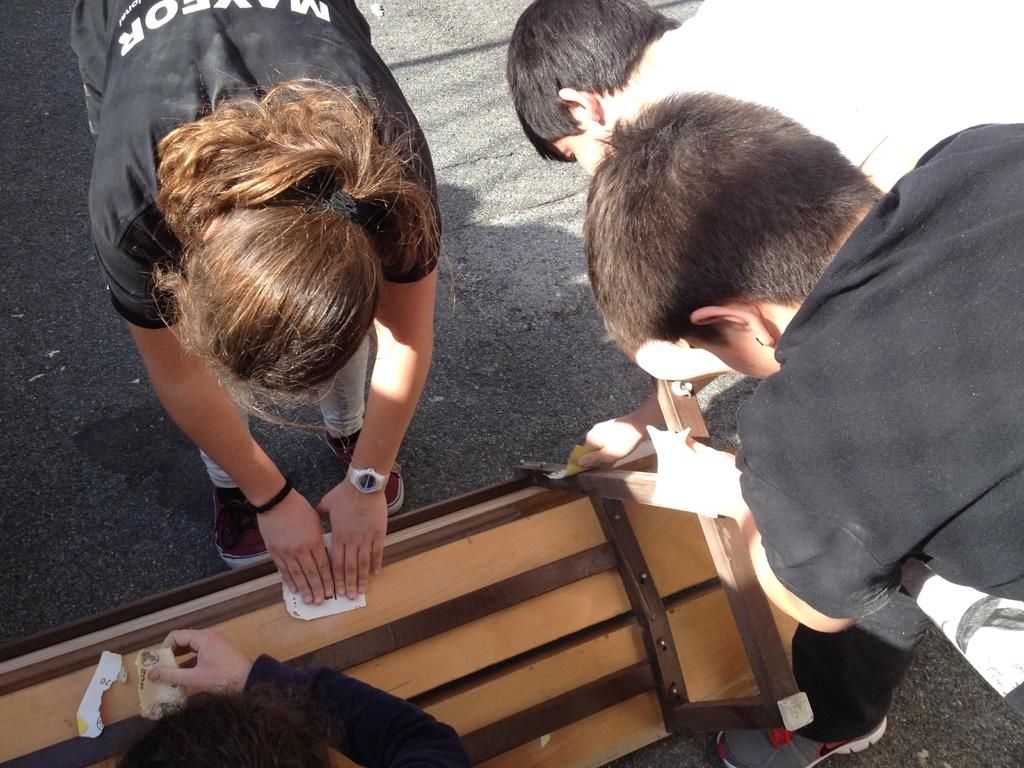How many people are standing on the road in the image? There are three people standing on the road in the image. What is the other person doing in the image? The other person is holding a piece of paper. Can you describe any other objects or structures in the image? Yes, there is a bench in the image. What is the height of the square in the image? There is no square present in the image, so it is not possible to determine its height. 